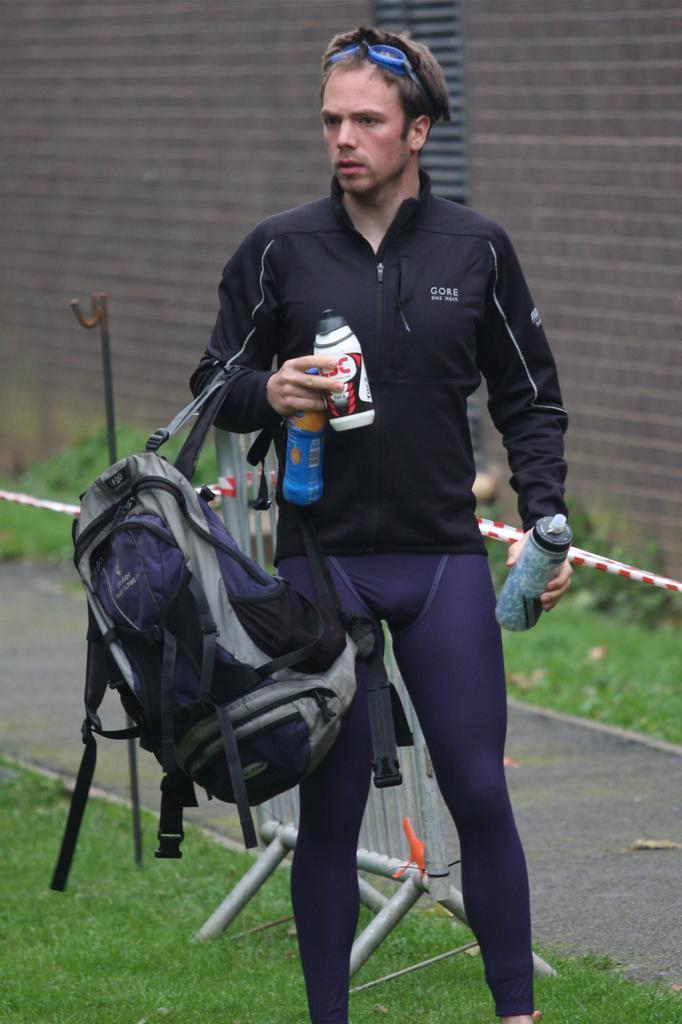Describe this image in one or two sentences. In this image, we can see a man is standing. He hold a bag and 2 bottles on his right hand and one bottle on his left hand. Behind him, we can see a barricade. there is a grass on the floor. And we can see a background a wall. And a rope we can see here. And few plants here. 